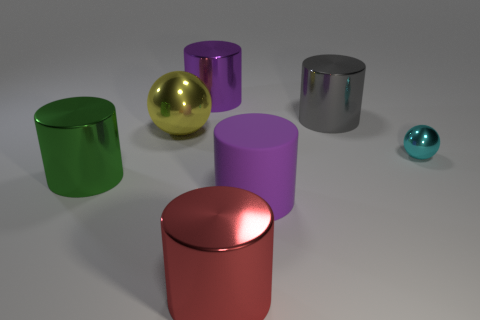Subtract all green cylinders. How many cylinders are left? 4 Subtract all green cylinders. How many cylinders are left? 4 Subtract all yellow cylinders. Subtract all yellow spheres. How many cylinders are left? 5 Add 2 brown metal blocks. How many objects exist? 9 Subtract 0 brown balls. How many objects are left? 7 Subtract all cylinders. How many objects are left? 2 Subtract all tiny yellow rubber blocks. Subtract all gray cylinders. How many objects are left? 6 Add 1 red things. How many red things are left? 2 Add 3 tiny yellow shiny cylinders. How many tiny yellow shiny cylinders exist? 3 